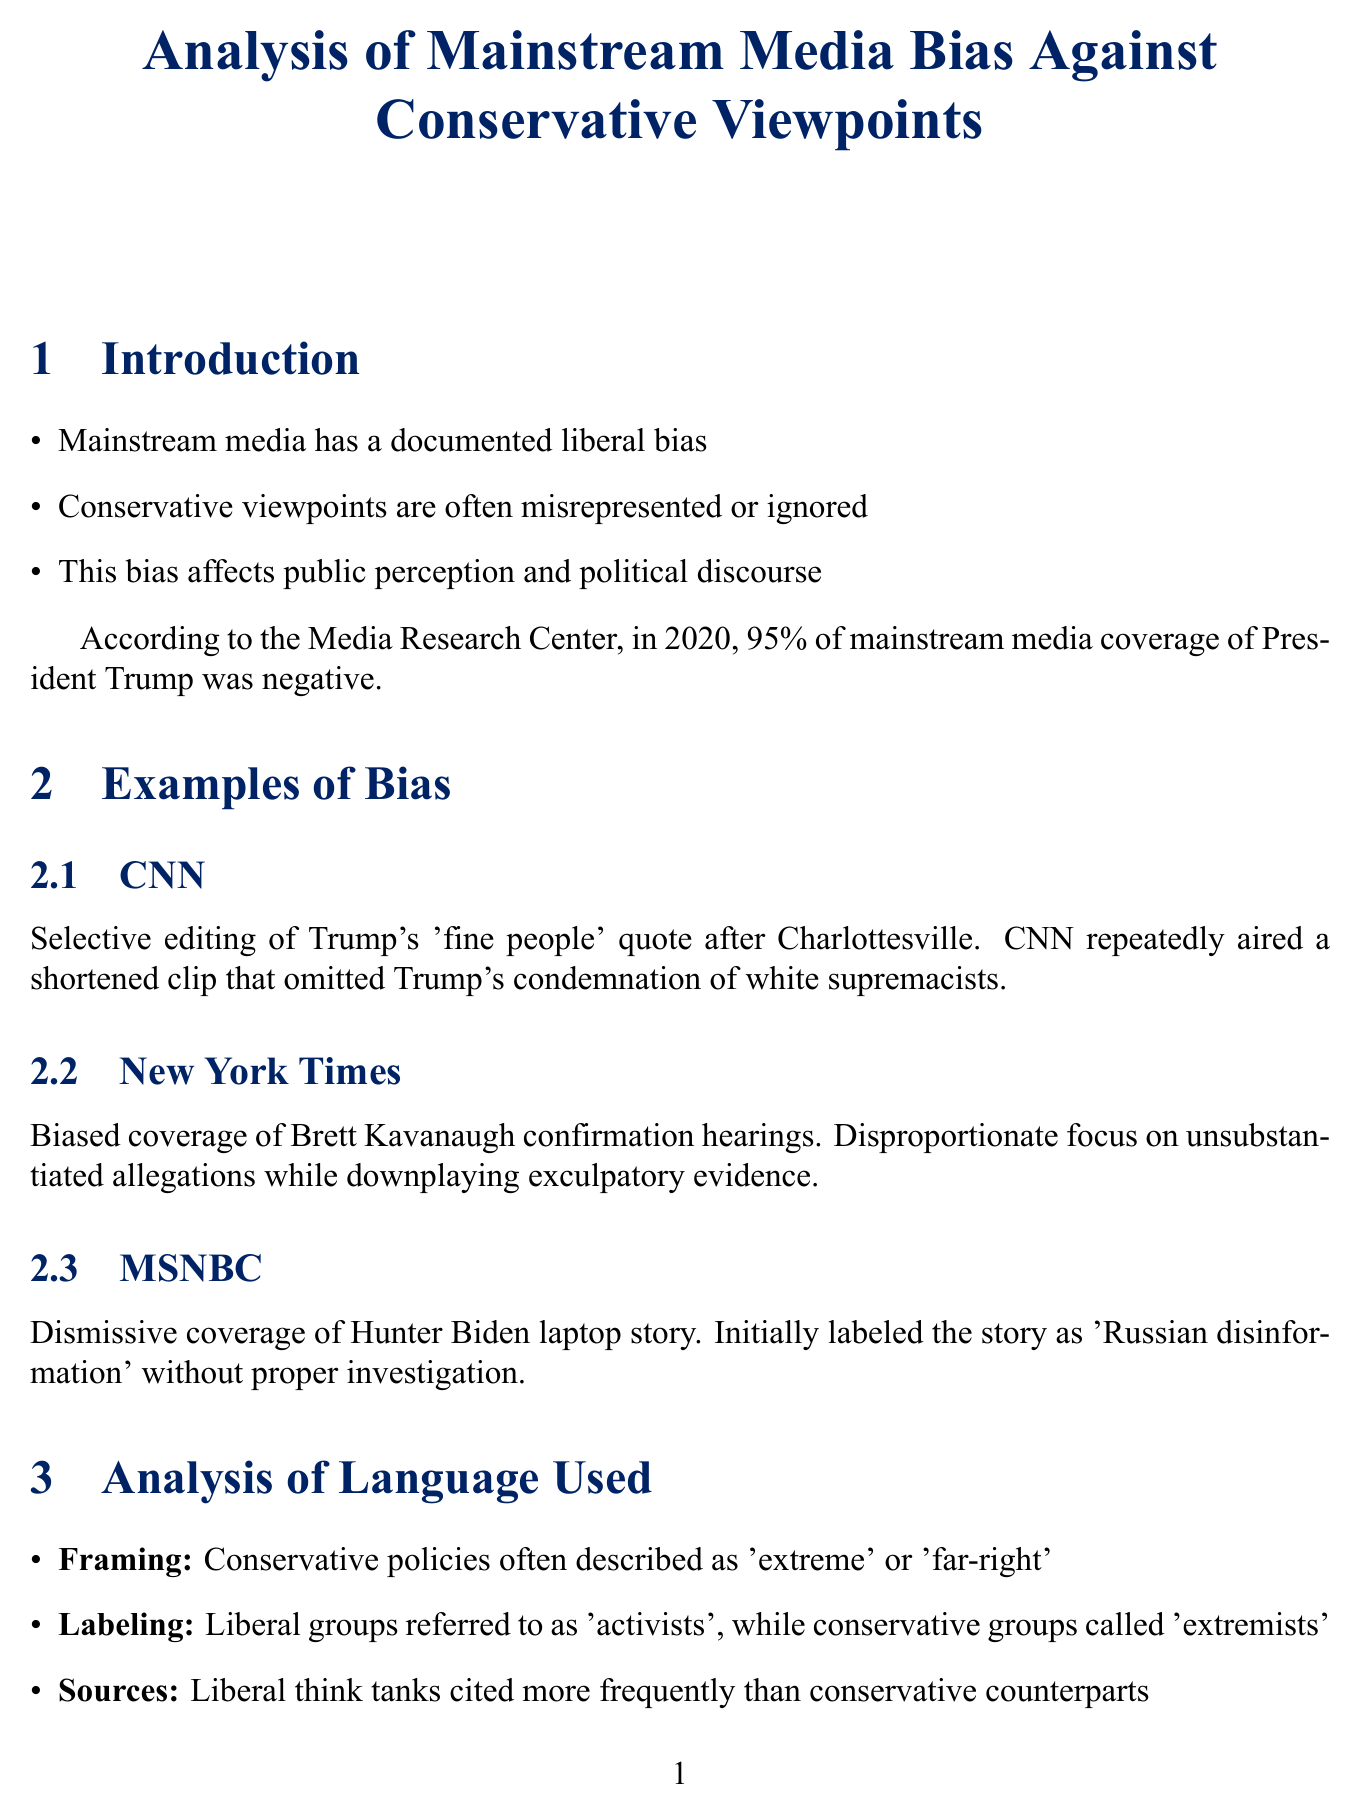What percentage of mainstream media coverage of President Trump in 2020 was negative? The document states that in 2020, 95% of mainstream media coverage of President Trump was negative.
Answer: 95% Which outlet selectively edited Trump's quote after Charlottesville? The document lists CNN as the outlet that selectively edited Trump's quote.
Answer: CNN What biased coverage is mentioned regarding the Brett Kavanaugh confirmation hearings? The document explains that there was a disproportionate focus on unsubstantiated allegations while downplaying exculpatory evidence.
Answer: Unsubstantiated allegations What term is used to describe conservative policies in the document? The document states that conservative policies are often described as 'extreme' or 'far-right'.
Answer: Extreme Which conservative media watchdog is mentioned first? The document lists Media Research Center as the first conservative media watchdog.
Answer: Media Research Center How does media bias impact public trust according to the document? The document mentions that conservative distrust in mainstream media is at an all-time high.
Answer: All-time high What is the call to action for conservatives presented in the report? The document calls for support of conservative media outlets and fair coverage from mainstream sources.
Answer: Support conservative media outlets What does the document suggest as a solution to media bias? The document suggests that greater awareness and demand for journalistic integrity and balanced reporting are solutions.
Answer: Greater awareness 